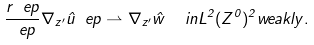Convert formula to latex. <formula><loc_0><loc_0><loc_500><loc_500>\frac { r _ { \ } e p } { \ e p } \nabla _ { z ^ { \prime } } \hat { u } _ { \ } e p \rightharpoonup \nabla _ { z ^ { \prime } } \hat { w } \ \ i n L ^ { 2 } ( Z ^ { 0 } ) ^ { 2 } w e a k l y .</formula> 